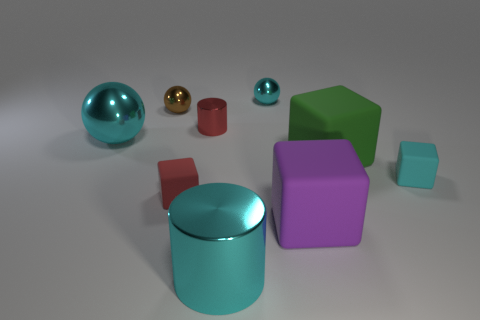There is a shiny cylinder that is the same color as the large ball; what size is it?
Offer a very short reply. Large. How many other objects are the same size as the green matte object?
Your answer should be very brief. 3. What is the shape of the tiny brown thing that is the same material as the small red cylinder?
Give a very brief answer. Sphere. Is the big cyan object right of the tiny brown object made of the same material as the red cube?
Your response must be concise. No. The matte object that is the same color as the large metallic cylinder is what shape?
Make the answer very short. Cube. There is a metallic cylinder that is in front of the big sphere; is its color the same as the sphere on the right side of the large cyan metal cylinder?
Provide a succinct answer. Yes. What number of large objects are to the left of the big purple object and behind the purple thing?
Offer a very short reply. 1. What is the material of the big green thing?
Ensure brevity in your answer.  Rubber. The other red object that is the same size as the red shiny object is what shape?
Make the answer very short. Cube. Do the big cyan thing that is in front of the cyan rubber thing and the purple thing in front of the big cyan sphere have the same material?
Provide a short and direct response. No. 